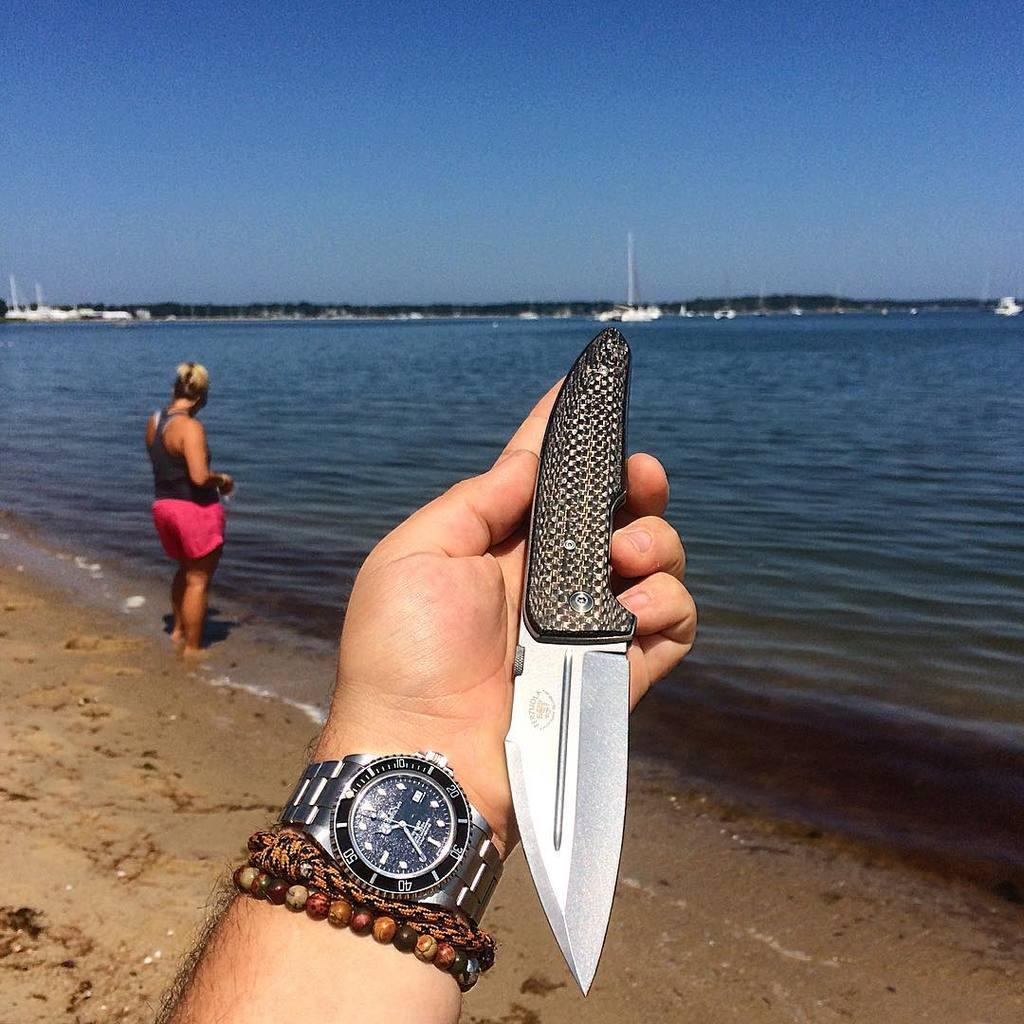<image>
Create a compact narrative representing the image presented. Someone is holding a knife at the beach, and according to their watch today is the 11th. 